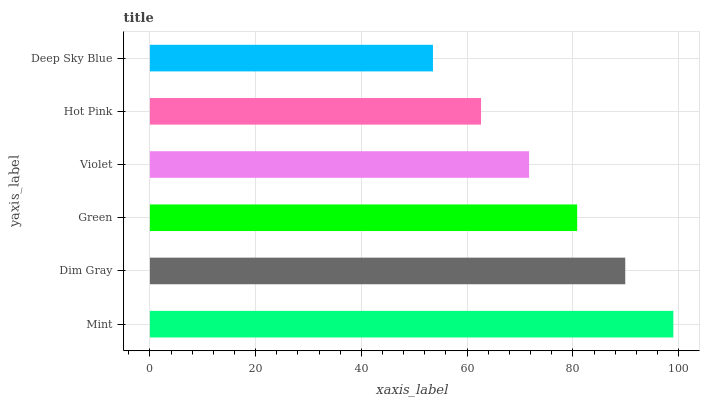Is Deep Sky Blue the minimum?
Answer yes or no. Yes. Is Mint the maximum?
Answer yes or no. Yes. Is Dim Gray the minimum?
Answer yes or no. No. Is Dim Gray the maximum?
Answer yes or no. No. Is Mint greater than Dim Gray?
Answer yes or no. Yes. Is Dim Gray less than Mint?
Answer yes or no. Yes. Is Dim Gray greater than Mint?
Answer yes or no. No. Is Mint less than Dim Gray?
Answer yes or no. No. Is Green the high median?
Answer yes or no. Yes. Is Violet the low median?
Answer yes or no. Yes. Is Dim Gray the high median?
Answer yes or no. No. Is Dim Gray the low median?
Answer yes or no. No. 